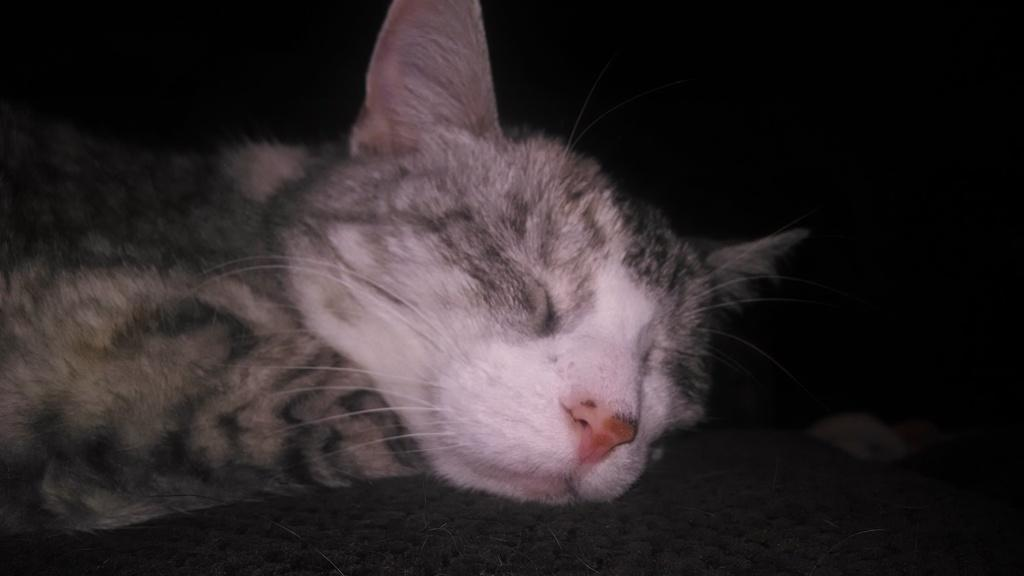What type of animal is in the image? There is a black cat in the image. What is the cat doing in the image? The cat is sleeping. What color is the background of the image? The background of the image is black. In what type of environment was the image taken? The image was taken in a dark environment. Is the cat stuck in quicksand in the image? No, there is no quicksand present in the image, and the cat is sleeping on a surface. What type of gate can be seen in the image? There is no gate present in the image; it features a black cat sleeping against a black background. 